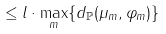Convert formula to latex. <formula><loc_0><loc_0><loc_500><loc_500>\leq l \cdot \max _ { m } \{ d _ { \mathbb { P } } ( \mu _ { m } , \varphi _ { m } ) \}</formula> 